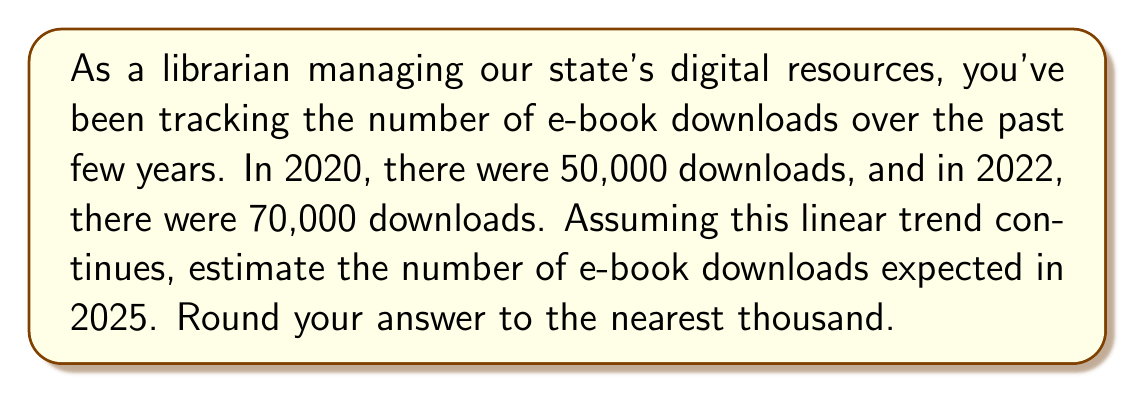Show me your answer to this math problem. To solve this problem, we'll use a linear equation to model the trend and then extrapolate to estimate future downloads. Let's follow these steps:

1) First, let's define our variables:
   $x$ = number of years since 2020
   $y$ = number of e-book downloads

2) We have two data points:
   (0, 50000) for 2020
   (2, 70000) for 2022

3) We can find the slope of the line using the point-slope formula:
   $$m = \frac{y_2 - y_1}{x_2 - x_1} = \frac{70000 - 50000}{2 - 0} = \frac{20000}{2} = 10000$$

4) This means the number of downloads is increasing by 10,000 per year.

5) We can now form our linear equation:
   $y = mx + b$, where $b$ is the y-intercept (50000 in this case)
   $$y = 10000x + 50000$$

6) To estimate downloads in 2025, we need to calculate for $x = 5$ (as 2025 is 5 years after 2020):
   $$y = 10000(5) + 50000 = 50000 + 50000 = 100000$$

Therefore, we estimate 100,000 e-book downloads in 2025.
Answer: 100,000 e-book downloads 